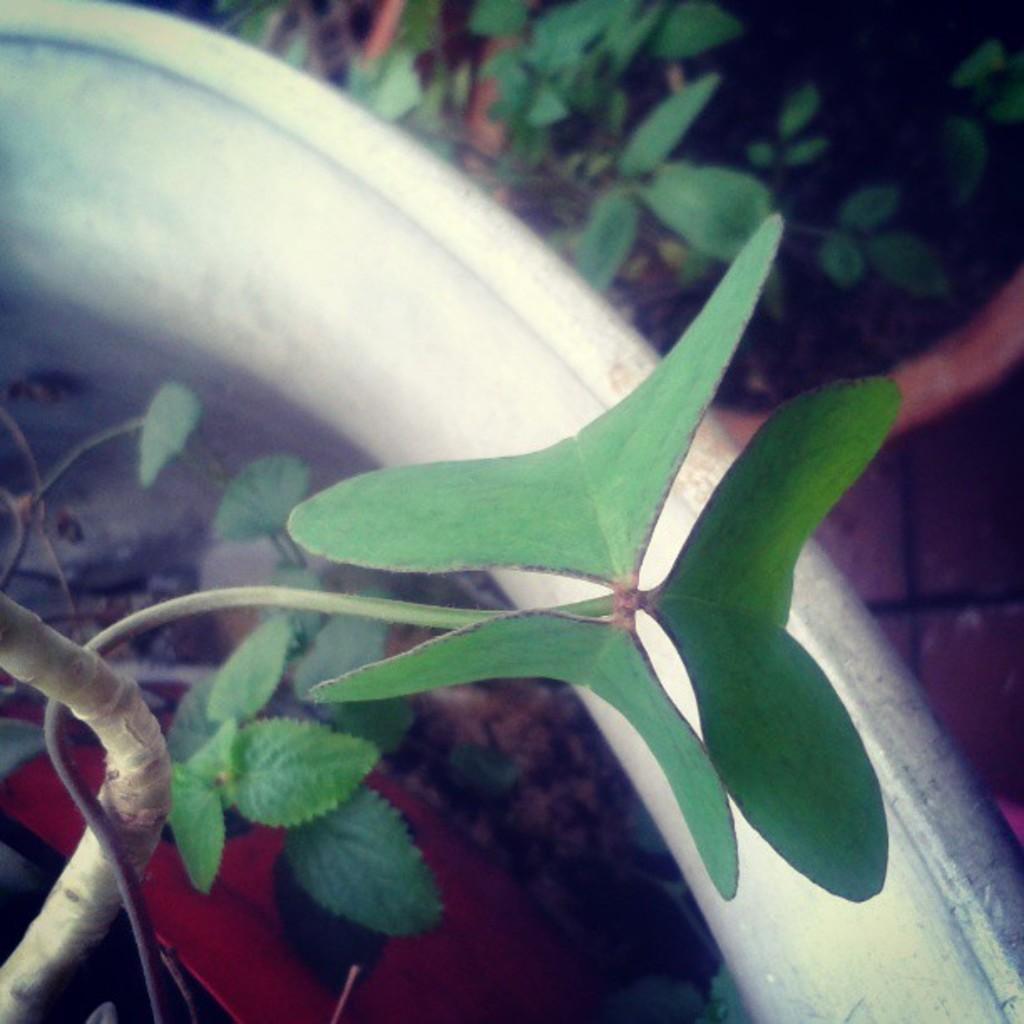How would you summarize this image in a sentence or two? In this image there are plants, there is an object that looks like a vegetable, there is a red color object towards the bottom of the image. 